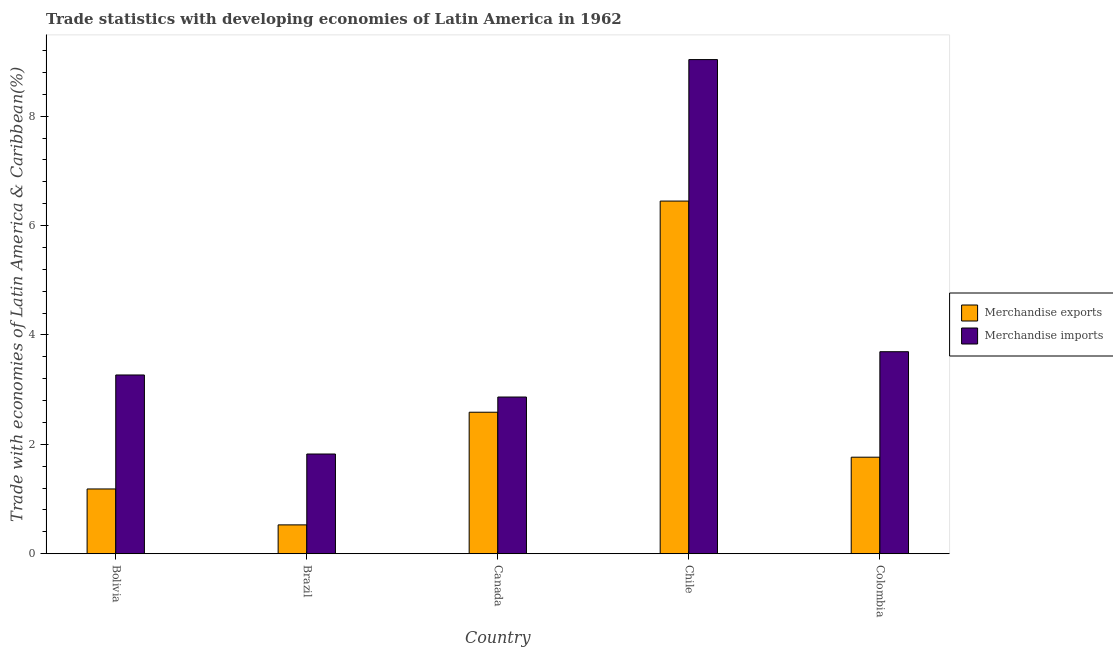How many groups of bars are there?
Offer a terse response. 5. Are the number of bars per tick equal to the number of legend labels?
Provide a short and direct response. Yes. Are the number of bars on each tick of the X-axis equal?
Keep it short and to the point. Yes. How many bars are there on the 2nd tick from the left?
Offer a very short reply. 2. How many bars are there on the 4th tick from the right?
Make the answer very short. 2. What is the merchandise imports in Chile?
Offer a very short reply. 9.04. Across all countries, what is the maximum merchandise imports?
Your answer should be very brief. 9.04. Across all countries, what is the minimum merchandise exports?
Make the answer very short. 0.53. In which country was the merchandise imports maximum?
Your response must be concise. Chile. What is the total merchandise exports in the graph?
Provide a succinct answer. 12.51. What is the difference between the merchandise imports in Brazil and that in Colombia?
Your answer should be compact. -1.87. What is the difference between the merchandise imports in Chile and the merchandise exports in Brazil?
Your answer should be very brief. 8.51. What is the average merchandise imports per country?
Your answer should be compact. 4.14. What is the difference between the merchandise imports and merchandise exports in Canada?
Ensure brevity in your answer.  0.28. What is the ratio of the merchandise exports in Canada to that in Colombia?
Provide a succinct answer. 1.47. Is the merchandise exports in Brazil less than that in Canada?
Ensure brevity in your answer.  Yes. Is the difference between the merchandise imports in Chile and Colombia greater than the difference between the merchandise exports in Chile and Colombia?
Keep it short and to the point. Yes. What is the difference between the highest and the second highest merchandise exports?
Give a very brief answer. 3.86. What is the difference between the highest and the lowest merchandise imports?
Offer a very short reply. 7.21. What does the 2nd bar from the left in Colombia represents?
Give a very brief answer. Merchandise imports. What does the 2nd bar from the right in Brazil represents?
Offer a very short reply. Merchandise exports. Are all the bars in the graph horizontal?
Provide a succinct answer. No. Does the graph contain any zero values?
Your answer should be compact. No. Does the graph contain grids?
Your answer should be very brief. No. Where does the legend appear in the graph?
Provide a short and direct response. Center right. How many legend labels are there?
Ensure brevity in your answer.  2. What is the title of the graph?
Offer a very short reply. Trade statistics with developing economies of Latin America in 1962. What is the label or title of the X-axis?
Offer a very short reply. Country. What is the label or title of the Y-axis?
Your answer should be compact. Trade with economies of Latin America & Caribbean(%). What is the Trade with economies of Latin America & Caribbean(%) in Merchandise exports in Bolivia?
Your response must be concise. 1.18. What is the Trade with economies of Latin America & Caribbean(%) of Merchandise imports in Bolivia?
Your answer should be very brief. 3.27. What is the Trade with economies of Latin America & Caribbean(%) in Merchandise exports in Brazil?
Ensure brevity in your answer.  0.53. What is the Trade with economies of Latin America & Caribbean(%) in Merchandise imports in Brazil?
Give a very brief answer. 1.82. What is the Trade with economies of Latin America & Caribbean(%) of Merchandise exports in Canada?
Provide a succinct answer. 2.59. What is the Trade with economies of Latin America & Caribbean(%) in Merchandise imports in Canada?
Your answer should be very brief. 2.87. What is the Trade with economies of Latin America & Caribbean(%) of Merchandise exports in Chile?
Provide a succinct answer. 6.45. What is the Trade with economies of Latin America & Caribbean(%) in Merchandise imports in Chile?
Offer a very short reply. 9.04. What is the Trade with economies of Latin America & Caribbean(%) in Merchandise exports in Colombia?
Your response must be concise. 1.77. What is the Trade with economies of Latin America & Caribbean(%) in Merchandise imports in Colombia?
Give a very brief answer. 3.69. Across all countries, what is the maximum Trade with economies of Latin America & Caribbean(%) of Merchandise exports?
Offer a terse response. 6.45. Across all countries, what is the maximum Trade with economies of Latin America & Caribbean(%) of Merchandise imports?
Offer a very short reply. 9.04. Across all countries, what is the minimum Trade with economies of Latin America & Caribbean(%) in Merchandise exports?
Offer a very short reply. 0.53. Across all countries, what is the minimum Trade with economies of Latin America & Caribbean(%) in Merchandise imports?
Give a very brief answer. 1.82. What is the total Trade with economies of Latin America & Caribbean(%) of Merchandise exports in the graph?
Provide a short and direct response. 12.51. What is the total Trade with economies of Latin America & Caribbean(%) in Merchandise imports in the graph?
Give a very brief answer. 20.69. What is the difference between the Trade with economies of Latin America & Caribbean(%) in Merchandise exports in Bolivia and that in Brazil?
Provide a short and direct response. 0.66. What is the difference between the Trade with economies of Latin America & Caribbean(%) of Merchandise imports in Bolivia and that in Brazil?
Your response must be concise. 1.45. What is the difference between the Trade with economies of Latin America & Caribbean(%) of Merchandise exports in Bolivia and that in Canada?
Offer a terse response. -1.4. What is the difference between the Trade with economies of Latin America & Caribbean(%) in Merchandise imports in Bolivia and that in Canada?
Your answer should be very brief. 0.4. What is the difference between the Trade with economies of Latin America & Caribbean(%) in Merchandise exports in Bolivia and that in Chile?
Your answer should be compact. -5.26. What is the difference between the Trade with economies of Latin America & Caribbean(%) of Merchandise imports in Bolivia and that in Chile?
Provide a short and direct response. -5.77. What is the difference between the Trade with economies of Latin America & Caribbean(%) of Merchandise exports in Bolivia and that in Colombia?
Make the answer very short. -0.58. What is the difference between the Trade with economies of Latin America & Caribbean(%) of Merchandise imports in Bolivia and that in Colombia?
Your answer should be compact. -0.43. What is the difference between the Trade with economies of Latin America & Caribbean(%) of Merchandise exports in Brazil and that in Canada?
Make the answer very short. -2.06. What is the difference between the Trade with economies of Latin America & Caribbean(%) in Merchandise imports in Brazil and that in Canada?
Provide a succinct answer. -1.04. What is the difference between the Trade with economies of Latin America & Caribbean(%) in Merchandise exports in Brazil and that in Chile?
Offer a very short reply. -5.92. What is the difference between the Trade with economies of Latin America & Caribbean(%) in Merchandise imports in Brazil and that in Chile?
Offer a terse response. -7.21. What is the difference between the Trade with economies of Latin America & Caribbean(%) in Merchandise exports in Brazil and that in Colombia?
Provide a succinct answer. -1.24. What is the difference between the Trade with economies of Latin America & Caribbean(%) of Merchandise imports in Brazil and that in Colombia?
Your answer should be very brief. -1.87. What is the difference between the Trade with economies of Latin America & Caribbean(%) of Merchandise exports in Canada and that in Chile?
Make the answer very short. -3.86. What is the difference between the Trade with economies of Latin America & Caribbean(%) in Merchandise imports in Canada and that in Chile?
Provide a succinct answer. -6.17. What is the difference between the Trade with economies of Latin America & Caribbean(%) in Merchandise exports in Canada and that in Colombia?
Give a very brief answer. 0.82. What is the difference between the Trade with economies of Latin America & Caribbean(%) of Merchandise imports in Canada and that in Colombia?
Your response must be concise. -0.83. What is the difference between the Trade with economies of Latin America & Caribbean(%) of Merchandise exports in Chile and that in Colombia?
Offer a very short reply. 4.68. What is the difference between the Trade with economies of Latin America & Caribbean(%) of Merchandise imports in Chile and that in Colombia?
Provide a short and direct response. 5.34. What is the difference between the Trade with economies of Latin America & Caribbean(%) in Merchandise exports in Bolivia and the Trade with economies of Latin America & Caribbean(%) in Merchandise imports in Brazil?
Make the answer very short. -0.64. What is the difference between the Trade with economies of Latin America & Caribbean(%) in Merchandise exports in Bolivia and the Trade with economies of Latin America & Caribbean(%) in Merchandise imports in Canada?
Offer a very short reply. -1.68. What is the difference between the Trade with economies of Latin America & Caribbean(%) in Merchandise exports in Bolivia and the Trade with economies of Latin America & Caribbean(%) in Merchandise imports in Chile?
Ensure brevity in your answer.  -7.85. What is the difference between the Trade with economies of Latin America & Caribbean(%) in Merchandise exports in Bolivia and the Trade with economies of Latin America & Caribbean(%) in Merchandise imports in Colombia?
Your answer should be very brief. -2.51. What is the difference between the Trade with economies of Latin America & Caribbean(%) of Merchandise exports in Brazil and the Trade with economies of Latin America & Caribbean(%) of Merchandise imports in Canada?
Provide a succinct answer. -2.34. What is the difference between the Trade with economies of Latin America & Caribbean(%) in Merchandise exports in Brazil and the Trade with economies of Latin America & Caribbean(%) in Merchandise imports in Chile?
Keep it short and to the point. -8.51. What is the difference between the Trade with economies of Latin America & Caribbean(%) of Merchandise exports in Brazil and the Trade with economies of Latin America & Caribbean(%) of Merchandise imports in Colombia?
Make the answer very short. -3.17. What is the difference between the Trade with economies of Latin America & Caribbean(%) of Merchandise exports in Canada and the Trade with economies of Latin America & Caribbean(%) of Merchandise imports in Chile?
Provide a short and direct response. -6.45. What is the difference between the Trade with economies of Latin America & Caribbean(%) in Merchandise exports in Canada and the Trade with economies of Latin America & Caribbean(%) in Merchandise imports in Colombia?
Give a very brief answer. -1.11. What is the difference between the Trade with economies of Latin America & Caribbean(%) in Merchandise exports in Chile and the Trade with economies of Latin America & Caribbean(%) in Merchandise imports in Colombia?
Ensure brevity in your answer.  2.75. What is the average Trade with economies of Latin America & Caribbean(%) in Merchandise exports per country?
Keep it short and to the point. 2.5. What is the average Trade with economies of Latin America & Caribbean(%) in Merchandise imports per country?
Your answer should be very brief. 4.14. What is the difference between the Trade with economies of Latin America & Caribbean(%) in Merchandise exports and Trade with economies of Latin America & Caribbean(%) in Merchandise imports in Bolivia?
Provide a short and direct response. -2.08. What is the difference between the Trade with economies of Latin America & Caribbean(%) in Merchandise exports and Trade with economies of Latin America & Caribbean(%) in Merchandise imports in Brazil?
Provide a succinct answer. -1.3. What is the difference between the Trade with economies of Latin America & Caribbean(%) in Merchandise exports and Trade with economies of Latin America & Caribbean(%) in Merchandise imports in Canada?
Your answer should be very brief. -0.28. What is the difference between the Trade with economies of Latin America & Caribbean(%) in Merchandise exports and Trade with economies of Latin America & Caribbean(%) in Merchandise imports in Chile?
Provide a short and direct response. -2.59. What is the difference between the Trade with economies of Latin America & Caribbean(%) in Merchandise exports and Trade with economies of Latin America & Caribbean(%) in Merchandise imports in Colombia?
Offer a very short reply. -1.93. What is the ratio of the Trade with economies of Latin America & Caribbean(%) of Merchandise exports in Bolivia to that in Brazil?
Give a very brief answer. 2.25. What is the ratio of the Trade with economies of Latin America & Caribbean(%) in Merchandise imports in Bolivia to that in Brazil?
Your answer should be very brief. 1.79. What is the ratio of the Trade with economies of Latin America & Caribbean(%) of Merchandise exports in Bolivia to that in Canada?
Provide a succinct answer. 0.46. What is the ratio of the Trade with economies of Latin America & Caribbean(%) in Merchandise imports in Bolivia to that in Canada?
Keep it short and to the point. 1.14. What is the ratio of the Trade with economies of Latin America & Caribbean(%) of Merchandise exports in Bolivia to that in Chile?
Give a very brief answer. 0.18. What is the ratio of the Trade with economies of Latin America & Caribbean(%) of Merchandise imports in Bolivia to that in Chile?
Your response must be concise. 0.36. What is the ratio of the Trade with economies of Latin America & Caribbean(%) in Merchandise exports in Bolivia to that in Colombia?
Give a very brief answer. 0.67. What is the ratio of the Trade with economies of Latin America & Caribbean(%) in Merchandise imports in Bolivia to that in Colombia?
Offer a terse response. 0.88. What is the ratio of the Trade with economies of Latin America & Caribbean(%) of Merchandise exports in Brazil to that in Canada?
Make the answer very short. 0.2. What is the ratio of the Trade with economies of Latin America & Caribbean(%) in Merchandise imports in Brazil to that in Canada?
Your answer should be very brief. 0.64. What is the ratio of the Trade with economies of Latin America & Caribbean(%) in Merchandise exports in Brazil to that in Chile?
Offer a terse response. 0.08. What is the ratio of the Trade with economies of Latin America & Caribbean(%) in Merchandise imports in Brazil to that in Chile?
Give a very brief answer. 0.2. What is the ratio of the Trade with economies of Latin America & Caribbean(%) of Merchandise exports in Brazil to that in Colombia?
Offer a terse response. 0.3. What is the ratio of the Trade with economies of Latin America & Caribbean(%) in Merchandise imports in Brazil to that in Colombia?
Offer a very short reply. 0.49. What is the ratio of the Trade with economies of Latin America & Caribbean(%) in Merchandise exports in Canada to that in Chile?
Keep it short and to the point. 0.4. What is the ratio of the Trade with economies of Latin America & Caribbean(%) of Merchandise imports in Canada to that in Chile?
Provide a short and direct response. 0.32. What is the ratio of the Trade with economies of Latin America & Caribbean(%) in Merchandise exports in Canada to that in Colombia?
Your response must be concise. 1.47. What is the ratio of the Trade with economies of Latin America & Caribbean(%) of Merchandise imports in Canada to that in Colombia?
Offer a very short reply. 0.78. What is the ratio of the Trade with economies of Latin America & Caribbean(%) of Merchandise exports in Chile to that in Colombia?
Provide a short and direct response. 3.65. What is the ratio of the Trade with economies of Latin America & Caribbean(%) in Merchandise imports in Chile to that in Colombia?
Keep it short and to the point. 2.45. What is the difference between the highest and the second highest Trade with economies of Latin America & Caribbean(%) in Merchandise exports?
Offer a very short reply. 3.86. What is the difference between the highest and the second highest Trade with economies of Latin America & Caribbean(%) in Merchandise imports?
Your response must be concise. 5.34. What is the difference between the highest and the lowest Trade with economies of Latin America & Caribbean(%) of Merchandise exports?
Ensure brevity in your answer.  5.92. What is the difference between the highest and the lowest Trade with economies of Latin America & Caribbean(%) in Merchandise imports?
Your answer should be compact. 7.21. 